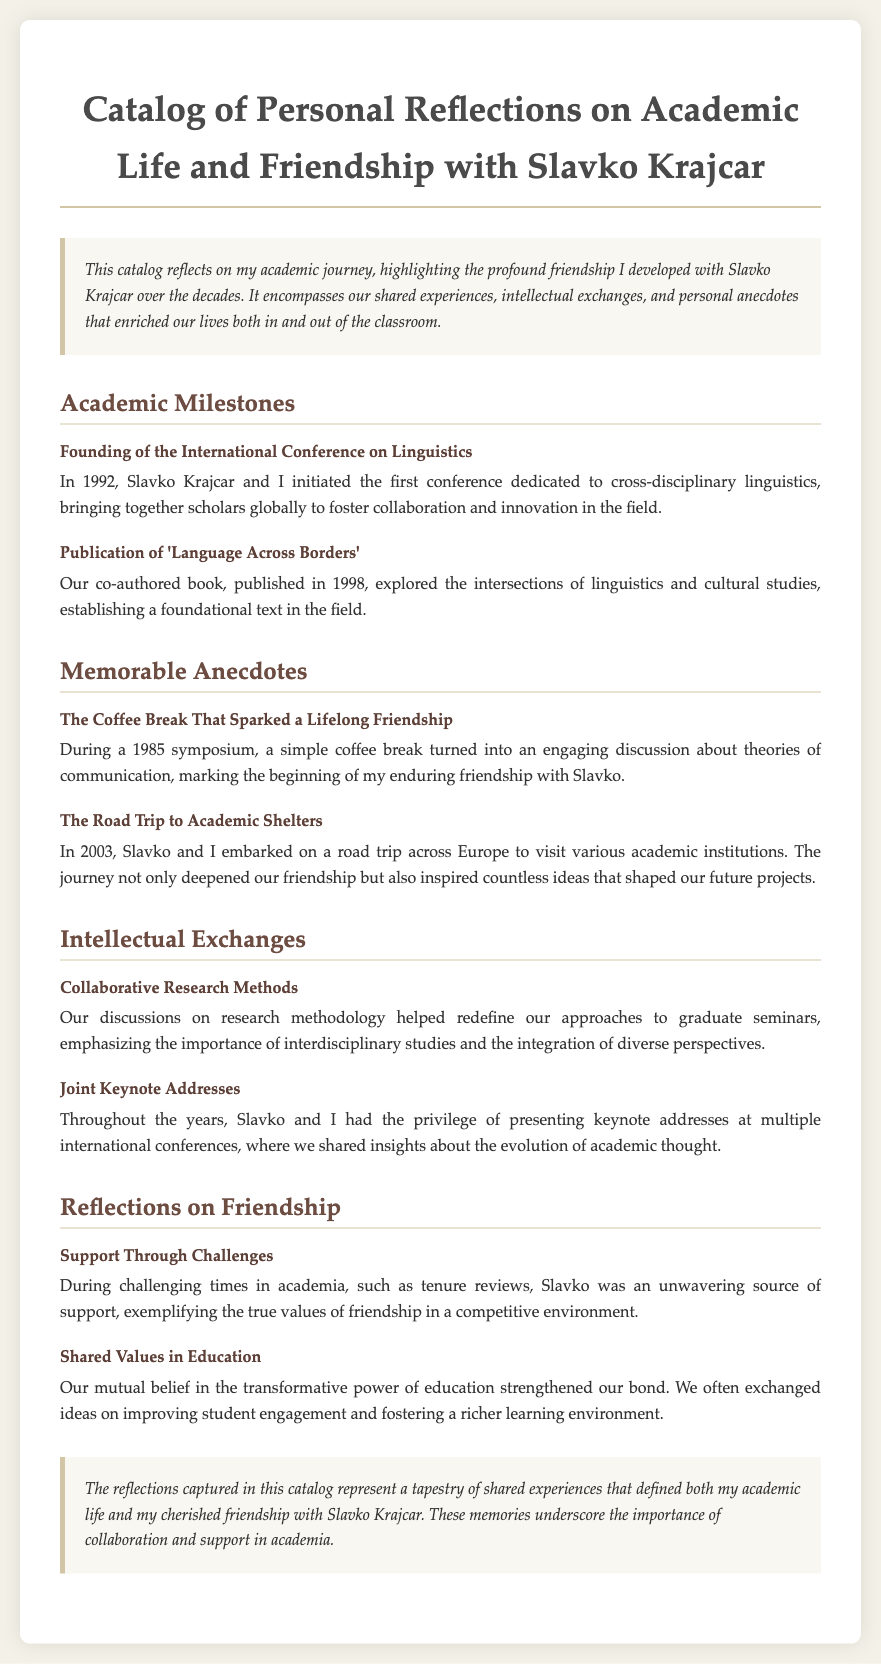What year was the International Conference on Linguistics founded? The document states that the conference was initiated in 1992, which is when it was founded.
Answer: 1992 What is the title of the co-authored book published in 1998? The book title mentioned for publication in 1998 is 'Language Across Borders'.
Answer: Language Across Borders What sparked the lifelong friendship with Slavko Krajcar? The friendship began during a 1985 symposium, specifically during a coffee break that led to an engaging discussion about theories of communication.
Answer: Coffee break What significant journey did the author and Slavko undertake in 2003? The document describes a road trip across Europe to visit various academic institutions, which was significant for their friendship.
Answer: Road trip What was a key theme in the intellectual exchanges between the author and Slavko? The exchanges focused on redefining research methodologies and emphasizing interdisciplinary studies and diverse perspectives.
Answer: Research methods What constituted the support Slavko provided during challenging times in academia? The support came during difficult situations such as tenure reviews, showing true values of friendship amid competition in academia.
Answer: Support through challenges How did the author and Slavko view education? The author reflects on their mutual belief in the transformative power of education, highlighting the values they shared in improving student engagement.
Answer: Shared values in education What is the overall theme of the catalog? The catalog reflects on shared experiences that shaped both the author's academic life and friendship with Slavko Krajcar, emphasizing collaboration and support.
Answer: Collaboration and support 